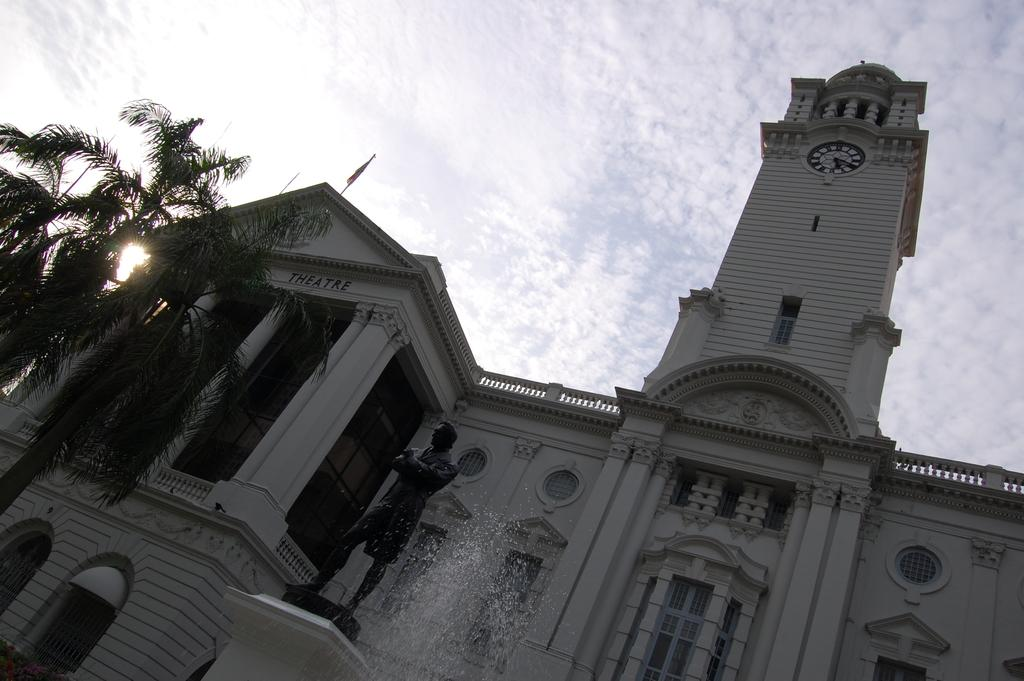What type of structure is present in the image? There is a building in the image. What other features can be seen in the image? There is a fountain, a statue, and trees in the image. How would you describe the sky in the image? The sky is bright in the image. How many birds are perched on the statue in the image? There are no birds present in the image; it only features a building, a fountain, a statue, trees, and a bright sky. Can you describe the stretch of the statue in the image? The statue does not have a stretchable feature, as it is a stationary object in the image. 